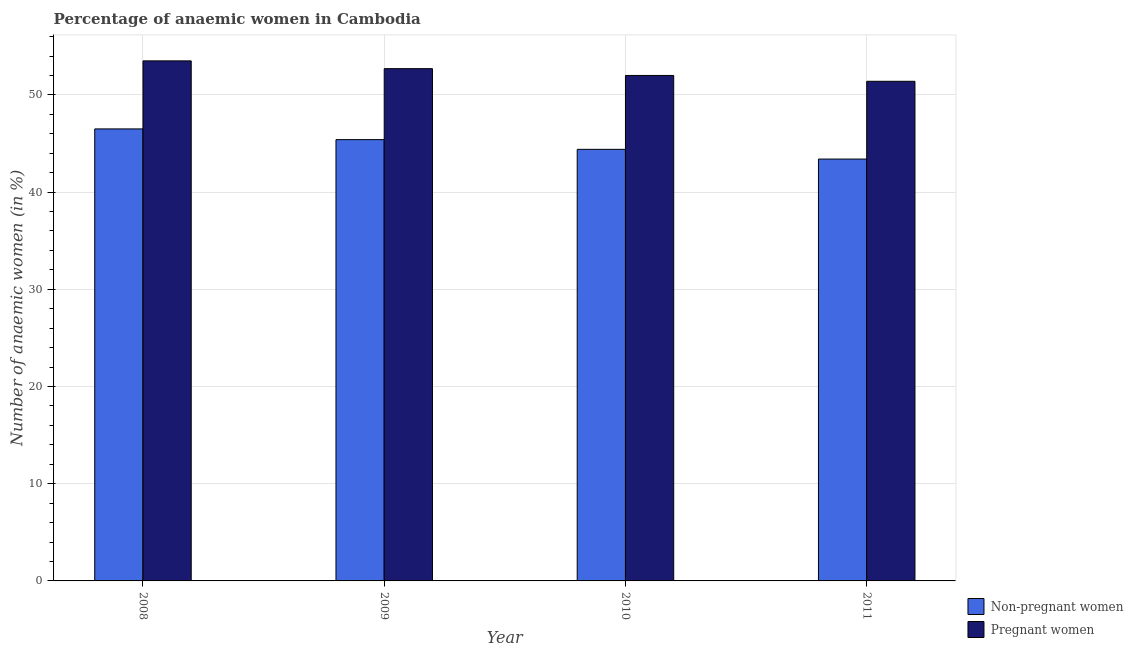How many groups of bars are there?
Ensure brevity in your answer.  4. Are the number of bars on each tick of the X-axis equal?
Keep it short and to the point. Yes. What is the label of the 4th group of bars from the left?
Your response must be concise. 2011. What is the percentage of pregnant anaemic women in 2009?
Make the answer very short. 52.7. Across all years, what is the maximum percentage of non-pregnant anaemic women?
Give a very brief answer. 46.5. Across all years, what is the minimum percentage of pregnant anaemic women?
Your answer should be very brief. 51.4. In which year was the percentage of pregnant anaemic women maximum?
Your response must be concise. 2008. In which year was the percentage of pregnant anaemic women minimum?
Offer a terse response. 2011. What is the total percentage of pregnant anaemic women in the graph?
Your answer should be compact. 209.6. What is the difference between the percentage of pregnant anaemic women in 2010 and that in 2011?
Provide a short and direct response. 0.6. What is the difference between the percentage of non-pregnant anaemic women in 2008 and the percentage of pregnant anaemic women in 2010?
Offer a terse response. 2.1. What is the average percentage of non-pregnant anaemic women per year?
Ensure brevity in your answer.  44.93. In how many years, is the percentage of non-pregnant anaemic women greater than 40 %?
Your response must be concise. 4. What is the ratio of the percentage of pregnant anaemic women in 2008 to that in 2010?
Offer a terse response. 1.03. Is the difference between the percentage of pregnant anaemic women in 2009 and 2011 greater than the difference between the percentage of non-pregnant anaemic women in 2009 and 2011?
Provide a short and direct response. No. What is the difference between the highest and the second highest percentage of non-pregnant anaemic women?
Make the answer very short. 1.1. What is the difference between the highest and the lowest percentage of non-pregnant anaemic women?
Give a very brief answer. 3.1. In how many years, is the percentage of non-pregnant anaemic women greater than the average percentage of non-pregnant anaemic women taken over all years?
Give a very brief answer. 2. What does the 2nd bar from the left in 2009 represents?
Provide a short and direct response. Pregnant women. What does the 1st bar from the right in 2008 represents?
Offer a terse response. Pregnant women. How many bars are there?
Provide a short and direct response. 8. How many years are there in the graph?
Give a very brief answer. 4. Does the graph contain grids?
Offer a very short reply. Yes. How many legend labels are there?
Your answer should be compact. 2. How are the legend labels stacked?
Offer a very short reply. Vertical. What is the title of the graph?
Ensure brevity in your answer.  Percentage of anaemic women in Cambodia. What is the label or title of the Y-axis?
Your response must be concise. Number of anaemic women (in %). What is the Number of anaemic women (in %) in Non-pregnant women in 2008?
Your response must be concise. 46.5. What is the Number of anaemic women (in %) in Pregnant women in 2008?
Provide a short and direct response. 53.5. What is the Number of anaemic women (in %) of Non-pregnant women in 2009?
Give a very brief answer. 45.4. What is the Number of anaemic women (in %) of Pregnant women in 2009?
Your answer should be very brief. 52.7. What is the Number of anaemic women (in %) of Non-pregnant women in 2010?
Keep it short and to the point. 44.4. What is the Number of anaemic women (in %) in Pregnant women in 2010?
Keep it short and to the point. 52. What is the Number of anaemic women (in %) of Non-pregnant women in 2011?
Provide a short and direct response. 43.4. What is the Number of anaemic women (in %) of Pregnant women in 2011?
Your answer should be very brief. 51.4. Across all years, what is the maximum Number of anaemic women (in %) of Non-pregnant women?
Your answer should be compact. 46.5. Across all years, what is the maximum Number of anaemic women (in %) of Pregnant women?
Your response must be concise. 53.5. Across all years, what is the minimum Number of anaemic women (in %) of Non-pregnant women?
Keep it short and to the point. 43.4. Across all years, what is the minimum Number of anaemic women (in %) in Pregnant women?
Keep it short and to the point. 51.4. What is the total Number of anaemic women (in %) of Non-pregnant women in the graph?
Your response must be concise. 179.7. What is the total Number of anaemic women (in %) of Pregnant women in the graph?
Your response must be concise. 209.6. What is the difference between the Number of anaemic women (in %) of Non-pregnant women in 2008 and that in 2009?
Ensure brevity in your answer.  1.1. What is the difference between the Number of anaemic women (in %) in Non-pregnant women in 2008 and that in 2010?
Your response must be concise. 2.1. What is the difference between the Number of anaemic women (in %) of Pregnant women in 2008 and that in 2011?
Your response must be concise. 2.1. What is the difference between the Number of anaemic women (in %) in Non-pregnant women in 2009 and that in 2010?
Your response must be concise. 1. What is the difference between the Number of anaemic women (in %) in Non-pregnant women in 2009 and that in 2011?
Keep it short and to the point. 2. What is the difference between the Number of anaemic women (in %) of Pregnant women in 2009 and that in 2011?
Provide a succinct answer. 1.3. What is the difference between the Number of anaemic women (in %) of Non-pregnant women in 2008 and the Number of anaemic women (in %) of Pregnant women in 2009?
Provide a short and direct response. -6.2. What is the difference between the Number of anaemic women (in %) of Non-pregnant women in 2009 and the Number of anaemic women (in %) of Pregnant women in 2011?
Offer a very short reply. -6. What is the average Number of anaemic women (in %) of Non-pregnant women per year?
Give a very brief answer. 44.92. What is the average Number of anaemic women (in %) of Pregnant women per year?
Your answer should be compact. 52.4. In the year 2010, what is the difference between the Number of anaemic women (in %) in Non-pregnant women and Number of anaemic women (in %) in Pregnant women?
Offer a very short reply. -7.6. What is the ratio of the Number of anaemic women (in %) in Non-pregnant women in 2008 to that in 2009?
Offer a terse response. 1.02. What is the ratio of the Number of anaemic women (in %) in Pregnant women in 2008 to that in 2009?
Offer a very short reply. 1.02. What is the ratio of the Number of anaemic women (in %) of Non-pregnant women in 2008 to that in 2010?
Your answer should be very brief. 1.05. What is the ratio of the Number of anaemic women (in %) of Pregnant women in 2008 to that in 2010?
Your response must be concise. 1.03. What is the ratio of the Number of anaemic women (in %) of Non-pregnant women in 2008 to that in 2011?
Give a very brief answer. 1.07. What is the ratio of the Number of anaemic women (in %) in Pregnant women in 2008 to that in 2011?
Ensure brevity in your answer.  1.04. What is the ratio of the Number of anaemic women (in %) in Non-pregnant women in 2009 to that in 2010?
Keep it short and to the point. 1.02. What is the ratio of the Number of anaemic women (in %) of Pregnant women in 2009 to that in 2010?
Keep it short and to the point. 1.01. What is the ratio of the Number of anaemic women (in %) of Non-pregnant women in 2009 to that in 2011?
Make the answer very short. 1.05. What is the ratio of the Number of anaemic women (in %) in Pregnant women in 2009 to that in 2011?
Offer a very short reply. 1.03. What is the ratio of the Number of anaemic women (in %) of Non-pregnant women in 2010 to that in 2011?
Your answer should be very brief. 1.02. What is the ratio of the Number of anaemic women (in %) in Pregnant women in 2010 to that in 2011?
Your answer should be very brief. 1.01. What is the difference between the highest and the second highest Number of anaemic women (in %) of Non-pregnant women?
Provide a short and direct response. 1.1. What is the difference between the highest and the second highest Number of anaemic women (in %) in Pregnant women?
Offer a terse response. 0.8. 